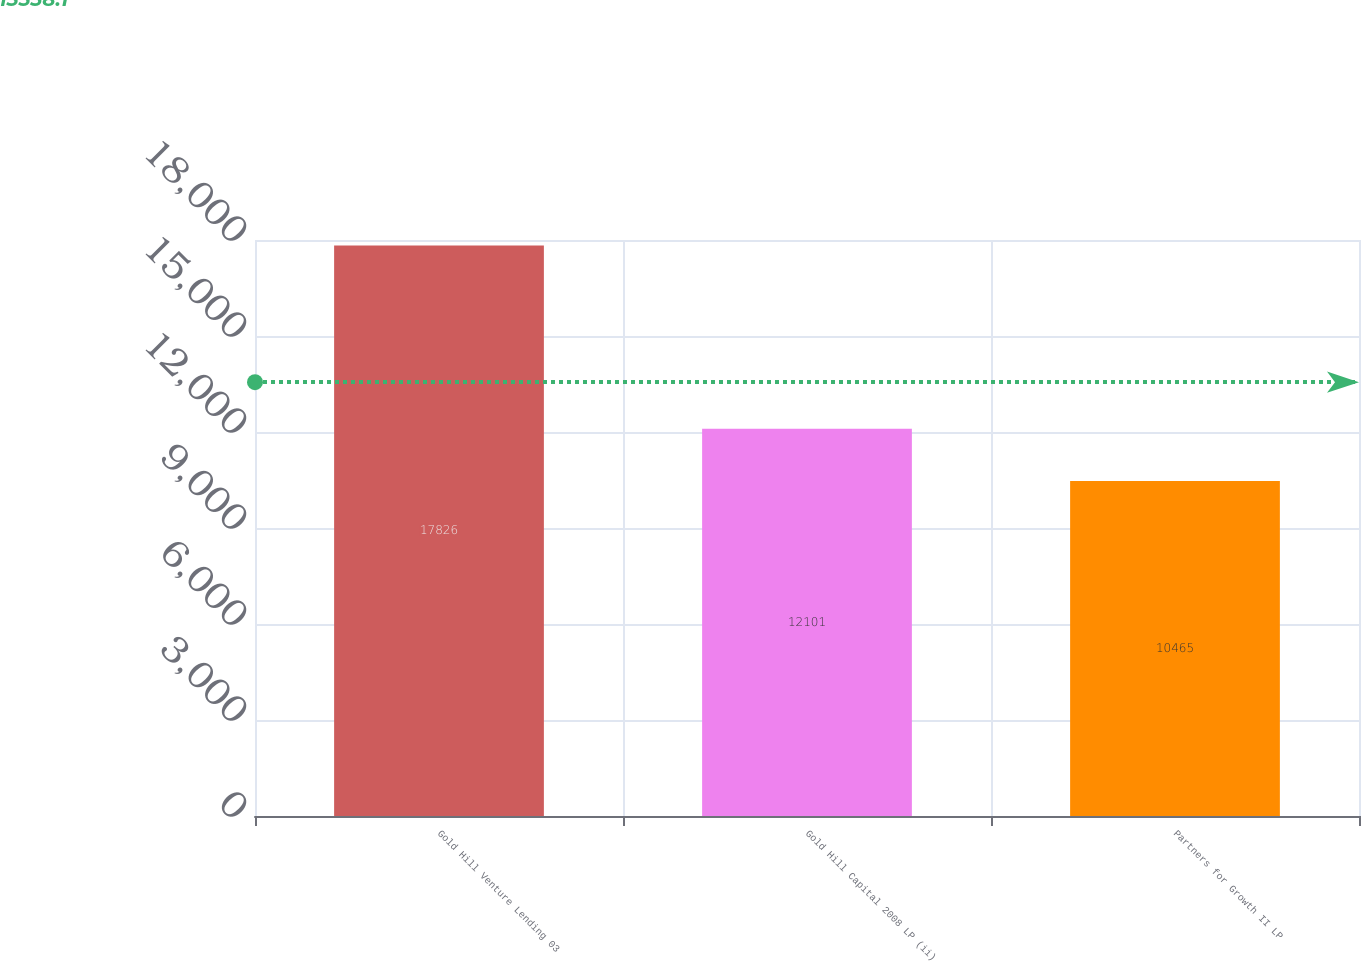Convert chart. <chart><loc_0><loc_0><loc_500><loc_500><bar_chart><fcel>Gold Hill Venture Lending 03<fcel>Gold Hill Capital 2008 LP (ii)<fcel>Partners for Growth II LP<nl><fcel>17826<fcel>12101<fcel>10465<nl></chart> 